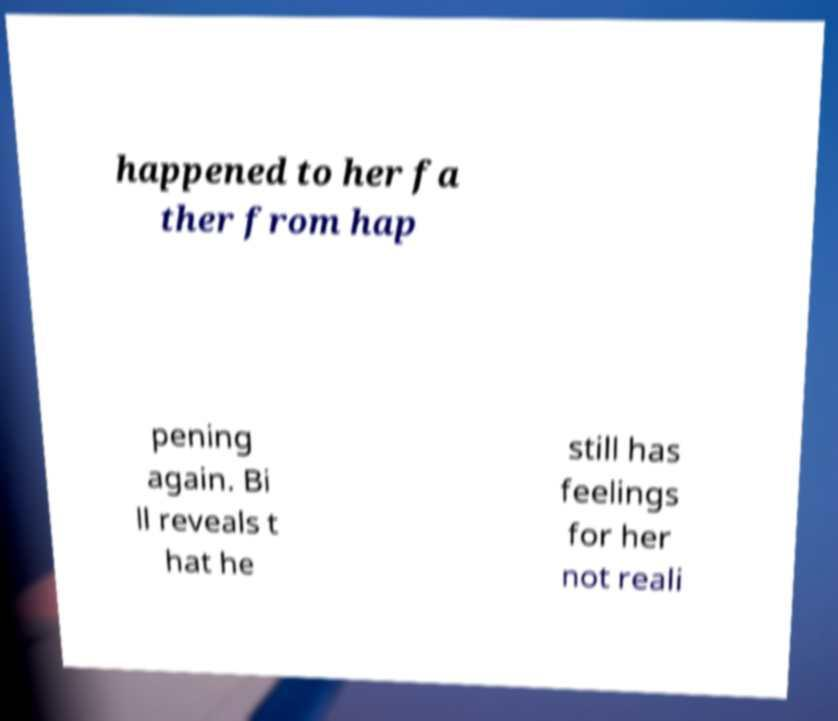Can you read and provide the text displayed in the image?This photo seems to have some interesting text. Can you extract and type it out for me? happened to her fa ther from hap pening again. Bi ll reveals t hat he still has feelings for her not reali 